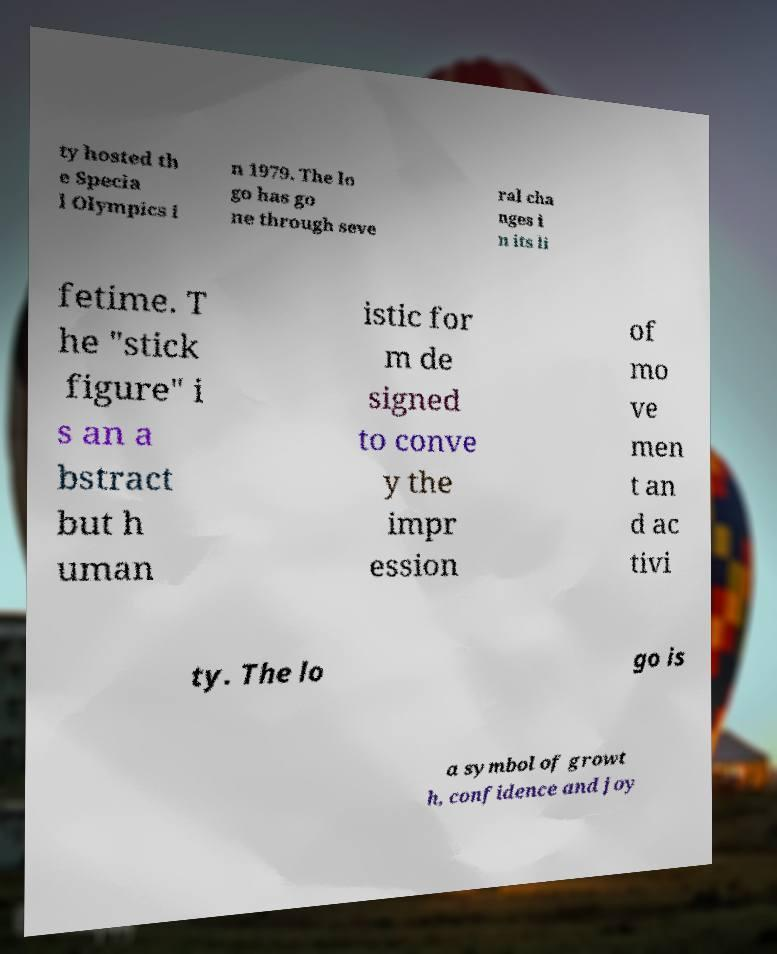Could you assist in decoding the text presented in this image and type it out clearly? ty hosted th e Specia l Olympics i n 1979. The lo go has go ne through seve ral cha nges i n its li fetime. T he "stick figure" i s an a bstract but h uman istic for m de signed to conve y the impr ession of mo ve men t an d ac tivi ty. The lo go is a symbol of growt h, confidence and joy 